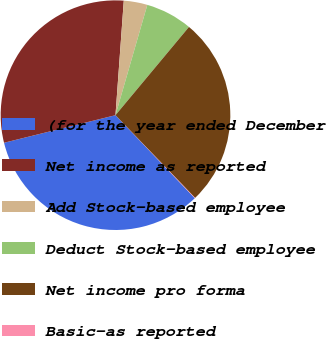Convert chart. <chart><loc_0><loc_0><loc_500><loc_500><pie_chart><fcel>(for the year ended December<fcel>Net income as reported<fcel>Add Stock-based employee<fcel>Deduct Stock-based employee<fcel>Net income pro forma<fcel>Basic-as reported<nl><fcel>33.27%<fcel>30.01%<fcel>3.32%<fcel>6.58%<fcel>26.75%<fcel>0.06%<nl></chart> 